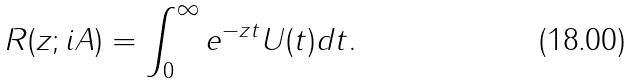Convert formula to latex. <formula><loc_0><loc_0><loc_500><loc_500>R ( z ; i A ) = \int _ { 0 } ^ { \infty } e ^ { - z t } U ( t ) d t .</formula> 